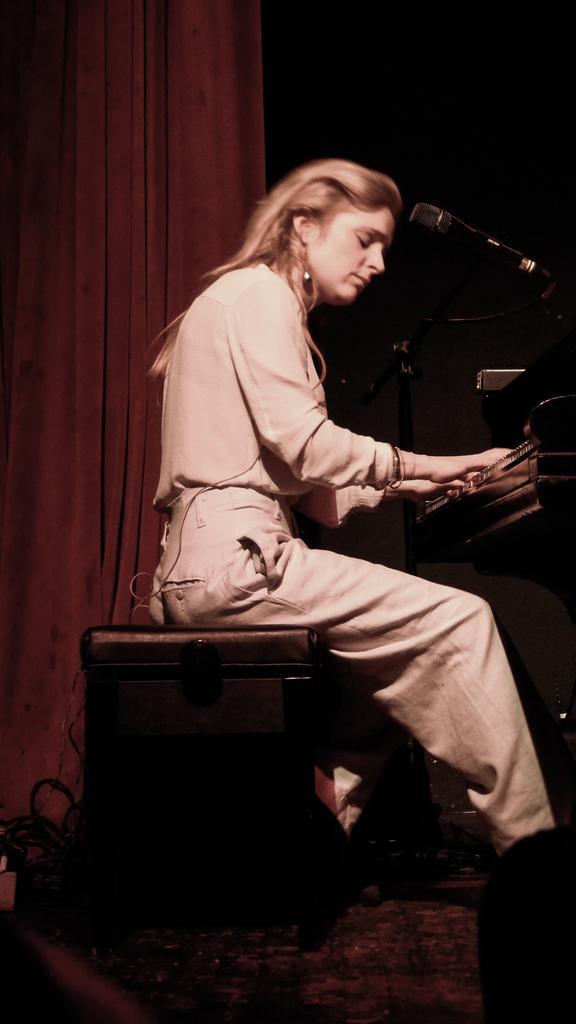Please provide a concise description of this image. There is a woman sitting on a stool and playing piano. This is a mike with a mike stand. At background I can see a Curtain hanging through the hanger. 